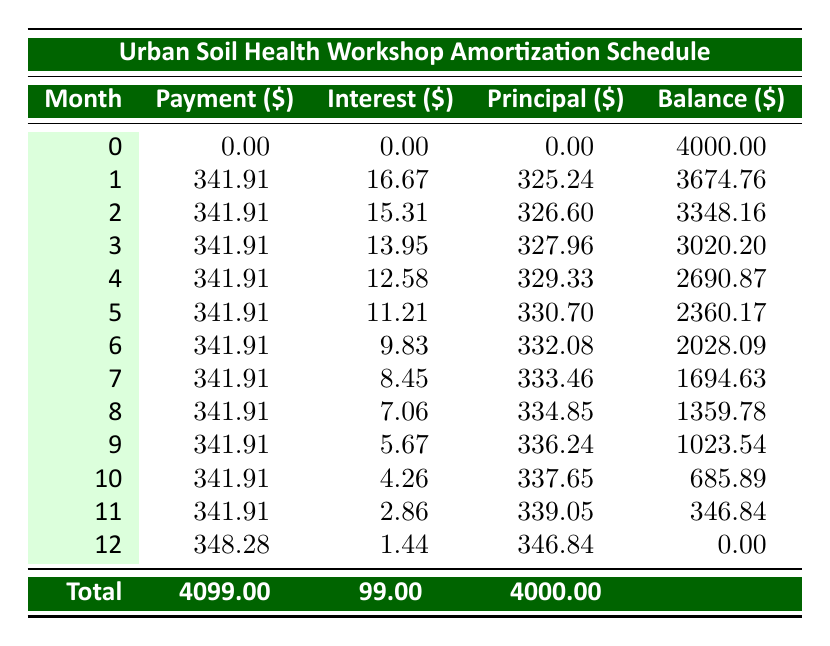What's the total cost of the Urban Soil Health Workshop? The total cost is listed in the workshop series section. It is stated directly as 5000.
Answer: 5000 What is the monthly payment amount for the loan? The monthly payment is specifically mentioned under the financing section, which is 341.91.
Answer: 341.91 What is the total amount paid for interest over the course of the loan? The total interest paid is also provided in the financing section, which is stated as 99.00.
Answer: 99.00 How much will be the balance after 6 months? To find the balance after 6 months, we look at the table for the month 6 entry. The balance is listed as 2028.09.
Answer: 2028.09 What is the total of principal payments made in the first 3 months? The principal payments for the first 3 months are found in the principal column for months 1, 2, and 3. They are 325.24, 326.60, and 327.96. Adding these gives 325.24 + 326.60 + 327.96 = 979.80.
Answer: 979.80 Is the total payment higher than the loan amount? The total payment made is 4099.00 which is greater than the loan amount of 4000, confirming that yes, it is higher.
Answer: Yes After 4 months, what will be the remaining balance? Checking the table for the month 4 entry, we find that the remaining balance is 2690.87.
Answer: 2690.87 What percentage of the total payments are interest payments? The total payments amount to 4099.00, and the total interest is 99.00. The percentage of payments that are interest is calculated as (99 / 4099) * 100, which equals approximately 2.42%.
Answer: 2.42% Does the monthly interest decrease over time? Observing the interest column from month 1 through month 12 shows that the interest value decreases from 16.67 down to 1.44. This verifies that interest payments do decrease.
Answer: Yes What is the average monthly payment over the 12 months? To find the average monthly payment, we divide the total payment of 4099.00 by the number of months (12) which results in approximately 341.58.
Answer: 341.58 